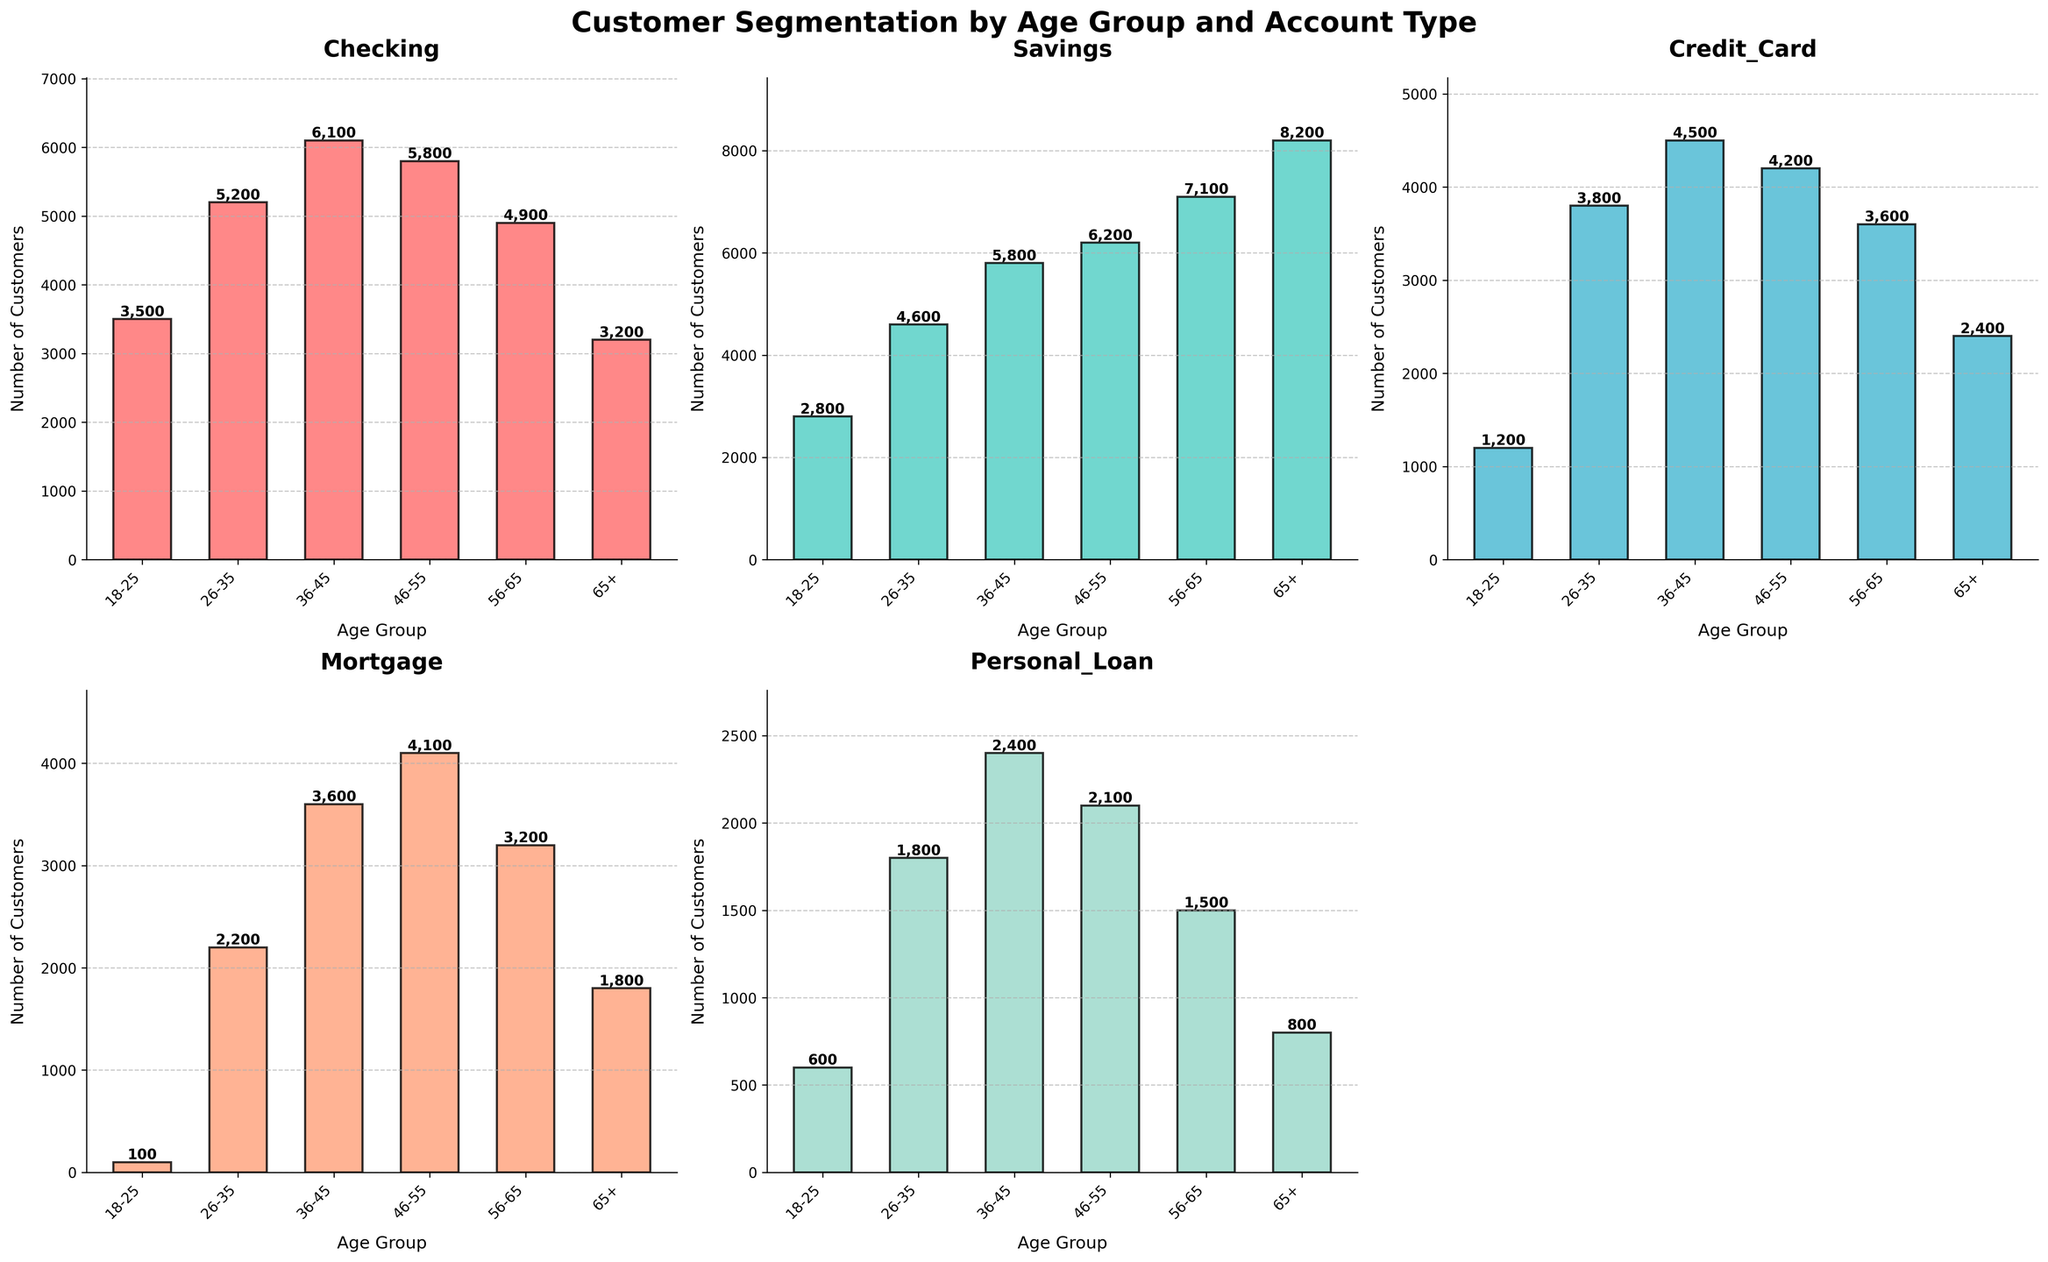What's the total number of customers aged 46-55 across all account types? Add the number of customers for each account type within the 46-55 age group: 5800 (Checking) + 6200 (Savings) + 4200 (Credit Card) + 4100 (Mortgage) + 2100 (Personal Loan)
Answer: 22,400 Which age group has the highest number of Savings accounts? Look at the Savings accounts bar for each age group and identify the tallest bar. The 65+ age group has the highest bar with 8200 customers
Answer: 65+ What is the difference in the number of Credit Card accounts between the 26-35 and 36-45 age groups? Subtract the number of Credit Card accounts in the 26-35 age group from the number in the 36-45 group: 4500 - 3800
Answer: 700 For which account type do customers aged 56-65 have the highest number compared to other types? Look at all account types for the 56-65 age group and compare the heights of the bars. Savings accounts have the highest number with 7100 customers
Answer: Savings How does the number of Checking accounts for the 18-25 age group compare to the 65+ age group? Compare the heights of the Checking accounts bars for the 18-25 and 65+ age groups. The 18-25 group has 3500 customers, and the 65+ group has 3200 customers, so the 18-25 group has more.
Answer: 18-25 has more What is the average number of Personal Loan accounts across all age groups? Calculate the average by summing the number of Personal Loan accounts for all age groups and dividing by the number of age groups: (600 + 1800 + 2400 + 2100 + 1500 + 800) / 6 = 9200 / 6
Answer: 1533 Which age group has the smallest number of Mortgage accounts? Compare the heights of the Mortgage accounts bars and identify the smallest one. The 18-25 age group has the smallest with 100 customers.
Answer: 18-25 What's the sum of the number of customers aged 26-35 and 46-55 for Savings accounts? Add the number of Savings accounts for customers aged 26-35 and 46-55: 4600 + 6200
Answer: 10,800 What is the ratio of Checking accounts to Credit Card accounts for the 36-45 age group? Calculate the ratio by dividing the number of Checking accounts by the number of Credit Card accounts for the 36-45 age group: 6100 / 4500
Answer: 1.36 How many total account types are plotted in the figures? Count the number of different account types that are plotted. There are Checking, Savings, Credit Card, Mortgage, and Personal Loan account types, which makes 5
Answer: 5 